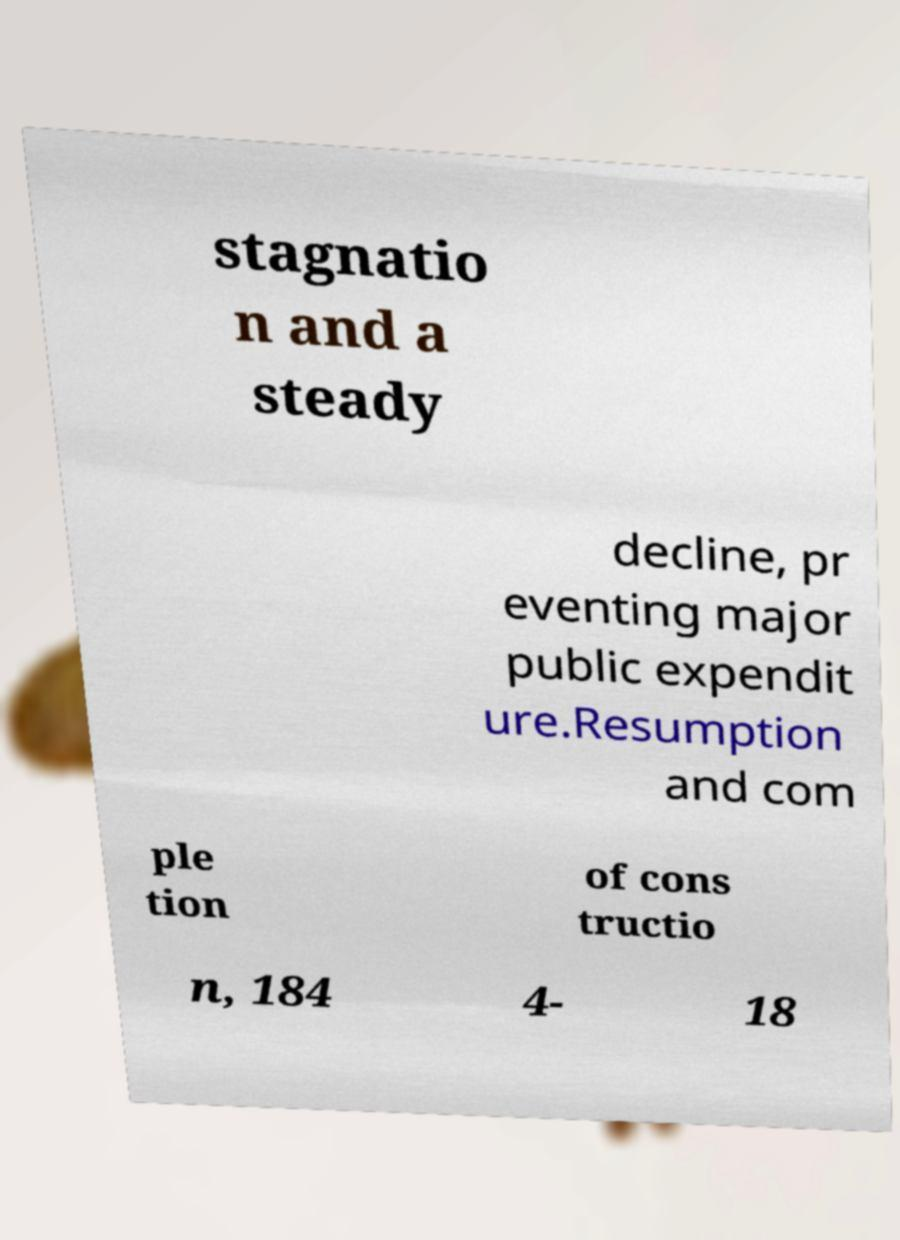Please identify and transcribe the text found in this image. stagnatio n and a steady decline, pr eventing major public expendit ure.Resumption and com ple tion of cons tructio n, 184 4- 18 